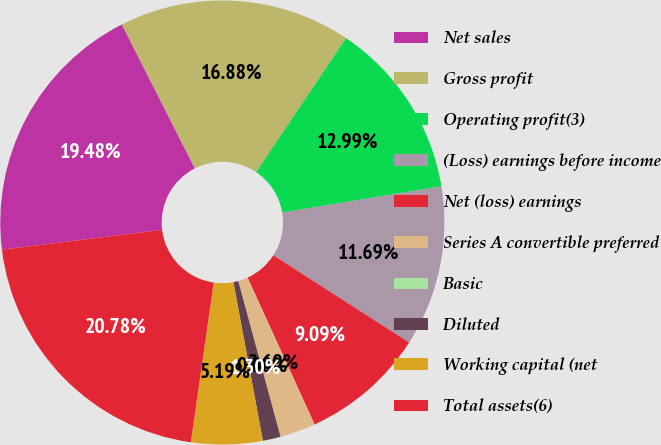<chart> <loc_0><loc_0><loc_500><loc_500><pie_chart><fcel>Net sales<fcel>Gross profit<fcel>Operating profit(3)<fcel>(Loss) earnings before income<fcel>Net (loss) earnings<fcel>Series A convertible preferred<fcel>Basic<fcel>Diluted<fcel>Working capital (net<fcel>Total assets(6)<nl><fcel>19.48%<fcel>16.88%<fcel>12.99%<fcel>11.69%<fcel>9.09%<fcel>2.6%<fcel>0.0%<fcel>1.3%<fcel>5.19%<fcel>20.78%<nl></chart> 